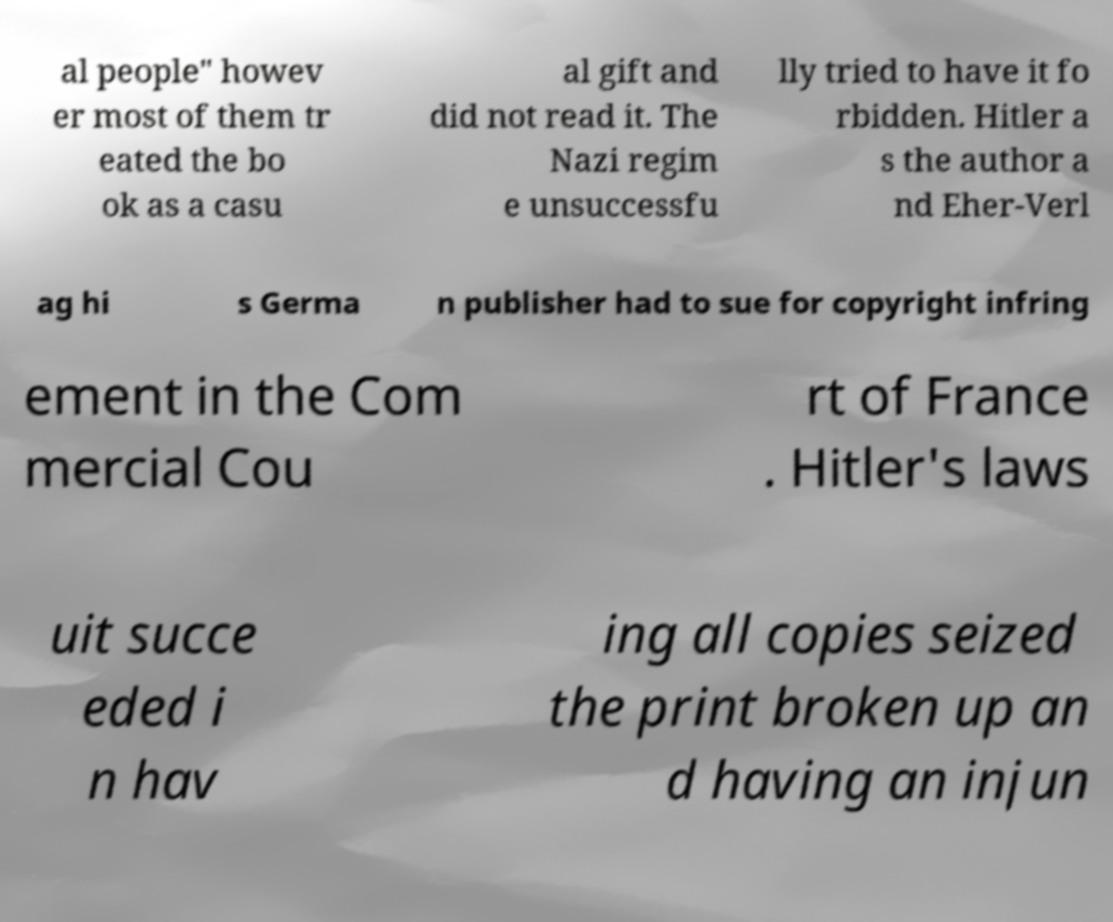Could you extract and type out the text from this image? al people" howev er most of them tr eated the bo ok as a casu al gift and did not read it. The Nazi regim e unsuccessfu lly tried to have it fo rbidden. Hitler a s the author a nd Eher-Verl ag hi s Germa n publisher had to sue for copyright infring ement in the Com mercial Cou rt of France . Hitler's laws uit succe eded i n hav ing all copies seized the print broken up an d having an injun 